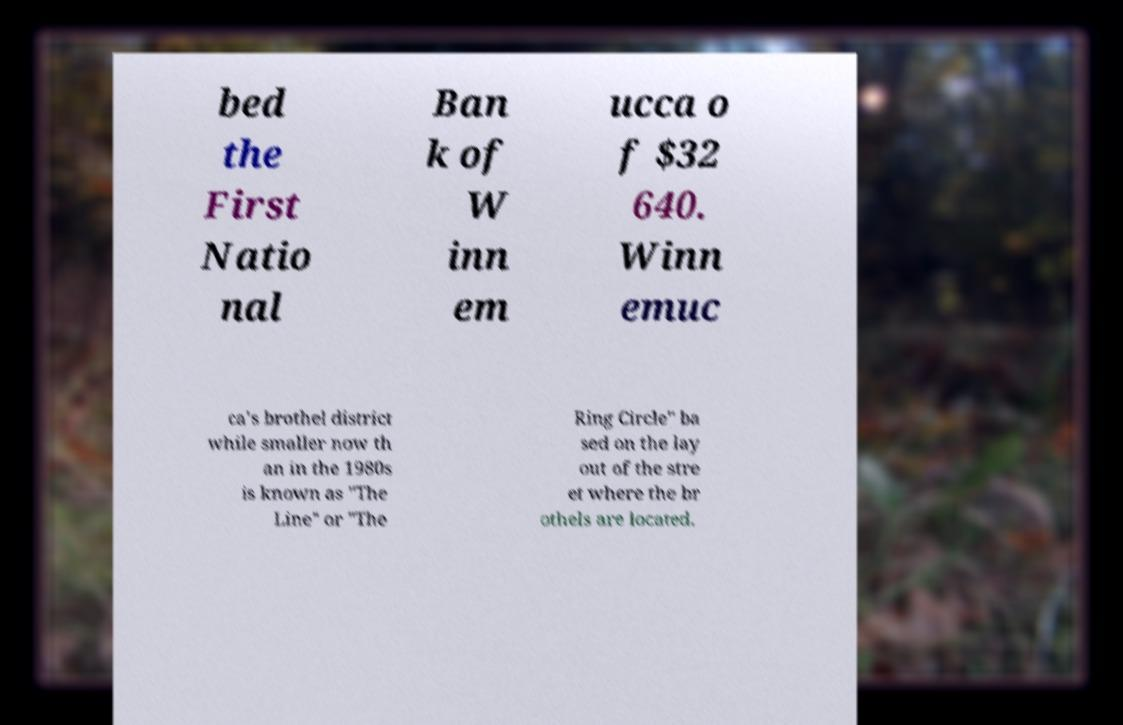Please read and relay the text visible in this image. What does it say? bed the First Natio nal Ban k of W inn em ucca o f $32 640. Winn emuc ca's brothel district while smaller now th an in the 1980s is known as "The Line" or "The Ring Circle" ba sed on the lay out of the stre et where the br othels are located. 